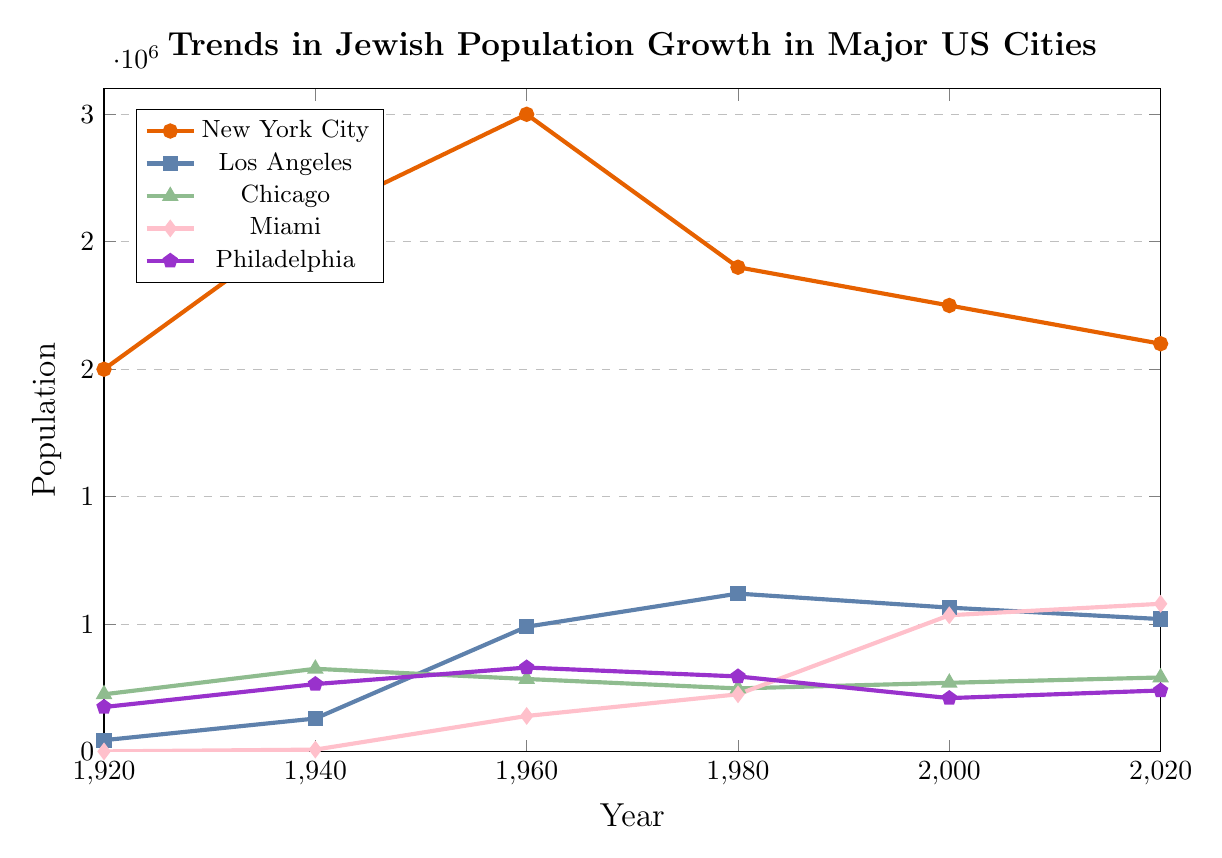Which city had the highest Jewish population in 1960? By examining the line chart, we can see that in 1960, New York City had the highest Jewish population.
Answer: New York City What is the total Jewish population in 2020 for all five cities combined? Add the population values for New York City, Los Angeles, Chicago, Miami, and Philadelphia in the year 2020. 1600000 + 520000 + 291000 + 580000 + 240000 = 3231000.
Answer: 3231000 How did the Jewish population trend for Los Angeles compare between 1920 and 2020? By examining the trend line for Los Angeles, we see that the Jewish population increased from 45000 in 1920 to 520000 in 2020, indicating a significant growth.
Answer: Increased In which decade did Miami experience the most substantial growth in its Jewish population? To determine this, we examine the differences between each decade for Miami. From 1940 to 1960, it went from 8000 to 140000, which is the most substantial increase.
Answer: 1940-1960 Which city had the largest decrease in Jewish population from 1960 to 1980? By examining the population values from 1960 to 1980 for each city, we see that New York City’s population dropped from 2500000 to 1900000, the largest decrease.
Answer: New York City What is the average Jewish population in Philadelphia over the entire period? To calculate the average, sum the population values (175000 + 265000 + 330000 + 295000 + 210000 + 240000 = 1515000) and divide by the number of data points (6). The average is 1515000/6 = 252500.
Answer: 252500 Which city showed the smallest change in Jewish population between 2000 and 2020? By comparing the populations for each city in 2000 and 2020, we find that Los Angeles experienced the smallest change (from 565000 to 520000, a decrease of just 45000).
Answer: Los Angeles In which year did Chicago have a Jewish population closest to its 1980 population level? Chicago’s population in 1980 was 248000. The closest value occurs in 2000, with a population of 270000.
Answer: 2000 How many increments in population did New York City experience from 1920 to 2020? By analyzing the trend line for New York City, we see increments in 1940, 1960, and decrements in 1980, 2000, and 2020, so there are two increments.
Answer: 2 What is the difference in the Jewish population between Miami and Philadelphia in 2020? Subtract the population of Philadelphia from that of Miami in 2020. 580000 - 240000 = 340000.
Answer: 340000 